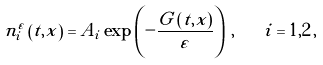Convert formula to latex. <formula><loc_0><loc_0><loc_500><loc_500>n _ { i } ^ { \varepsilon } \left ( t , x \right ) = A _ { i } \exp \left ( - \frac { G \left ( t , x \right ) } { \varepsilon } \right ) \, , \quad i = 1 , 2 \, ,</formula> 